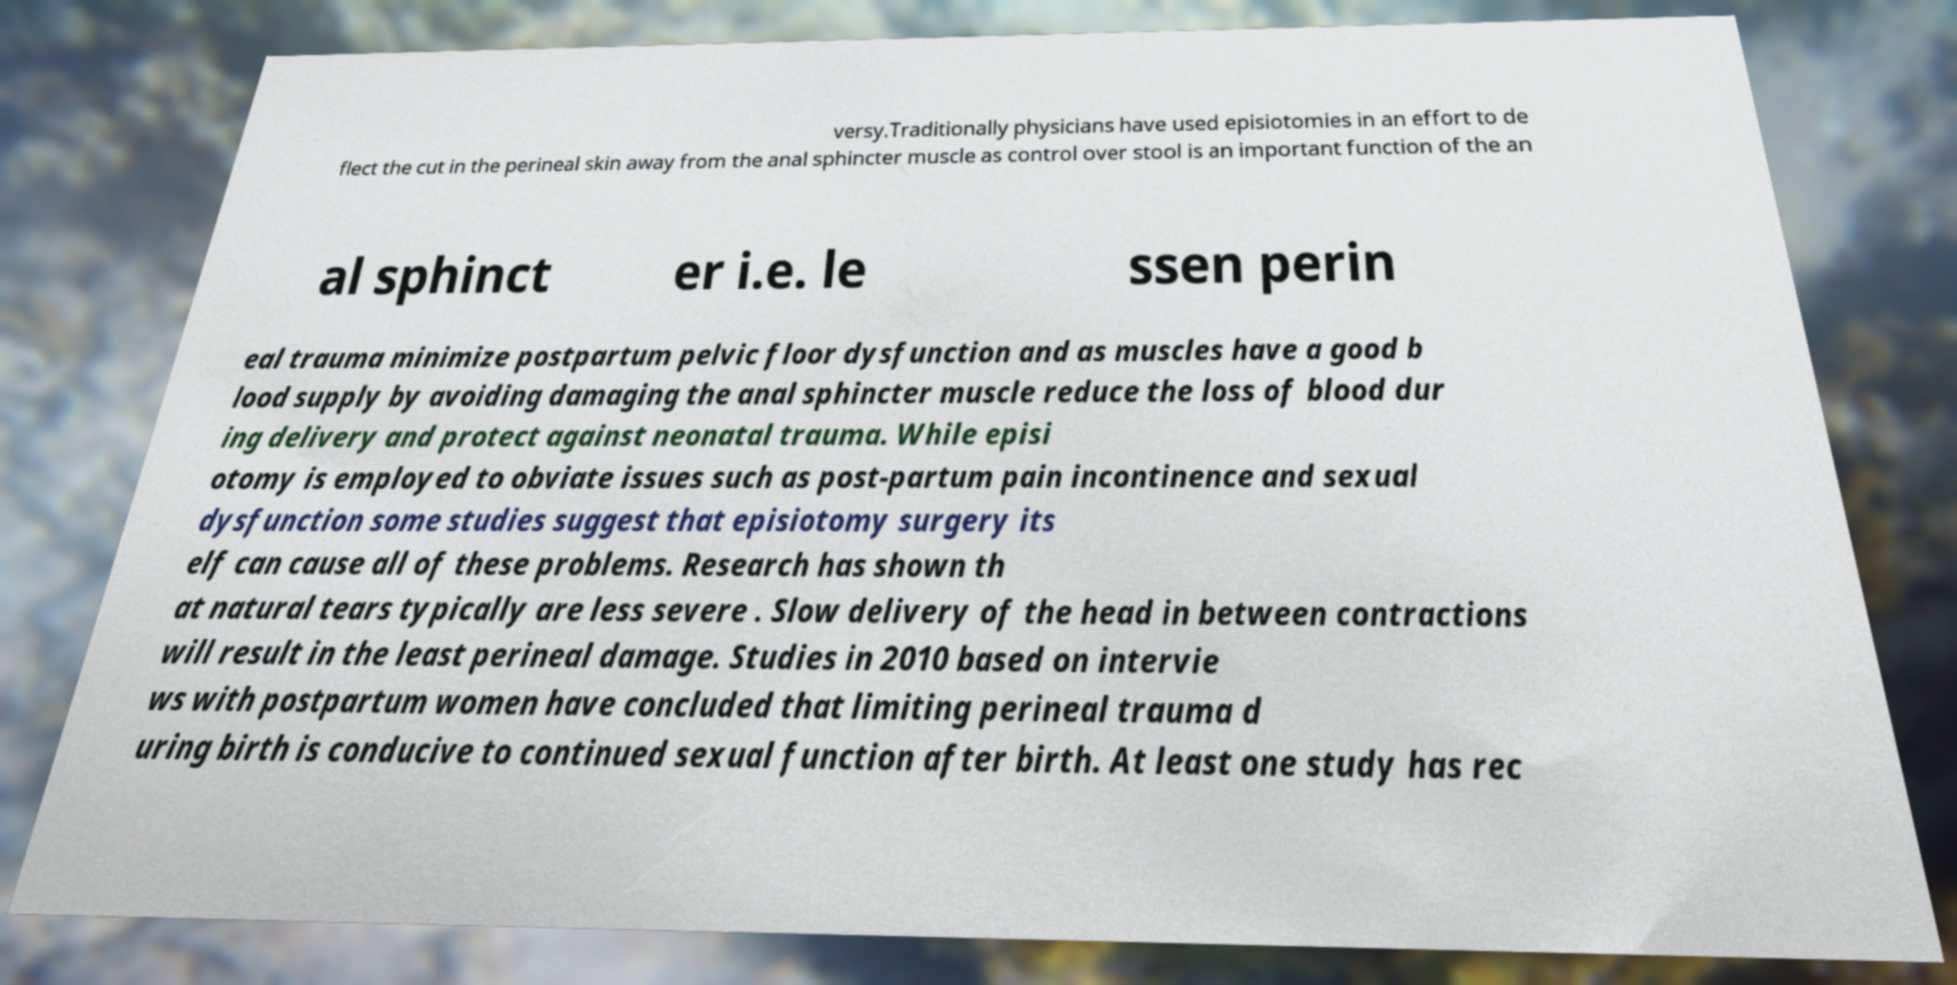Can you accurately transcribe the text from the provided image for me? versy.Traditionally physicians have used episiotomies in an effort to de flect the cut in the perineal skin away from the anal sphincter muscle as control over stool is an important function of the an al sphinct er i.e. le ssen perin eal trauma minimize postpartum pelvic floor dysfunction and as muscles have a good b lood supply by avoiding damaging the anal sphincter muscle reduce the loss of blood dur ing delivery and protect against neonatal trauma. While episi otomy is employed to obviate issues such as post-partum pain incontinence and sexual dysfunction some studies suggest that episiotomy surgery its elf can cause all of these problems. Research has shown th at natural tears typically are less severe . Slow delivery of the head in between contractions will result in the least perineal damage. Studies in 2010 based on intervie ws with postpartum women have concluded that limiting perineal trauma d uring birth is conducive to continued sexual function after birth. At least one study has rec 